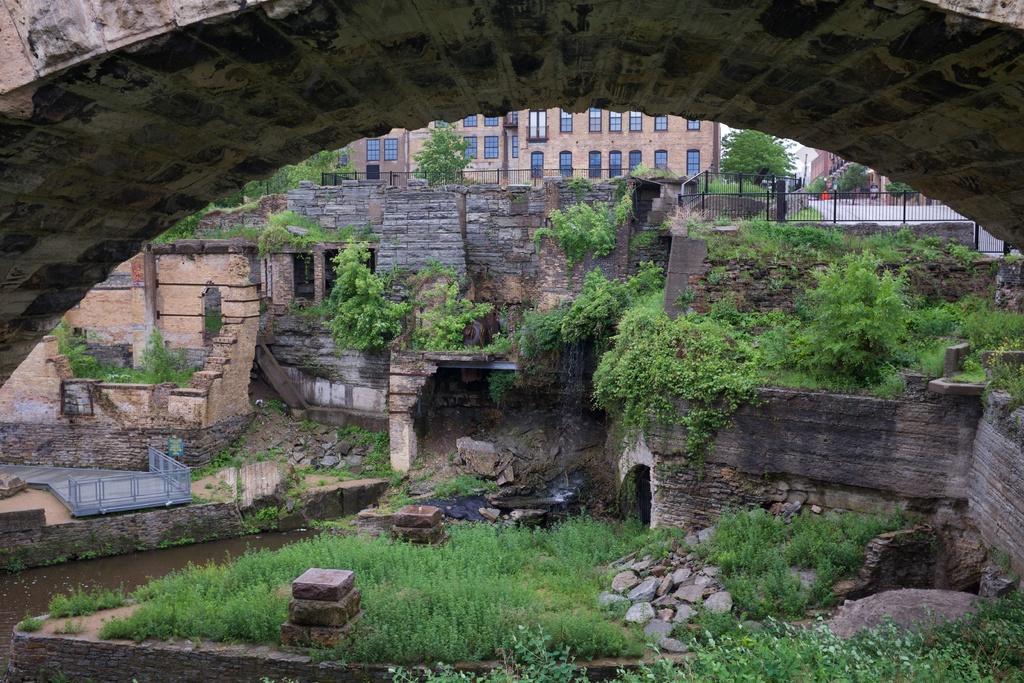Could you give a brief overview of what you see in this image? In this picture we can see a arch in the front of the image. Behind there is a damaged fort with some plants and grass. In the background there is a brown color building with glass windows and a metal railing. 